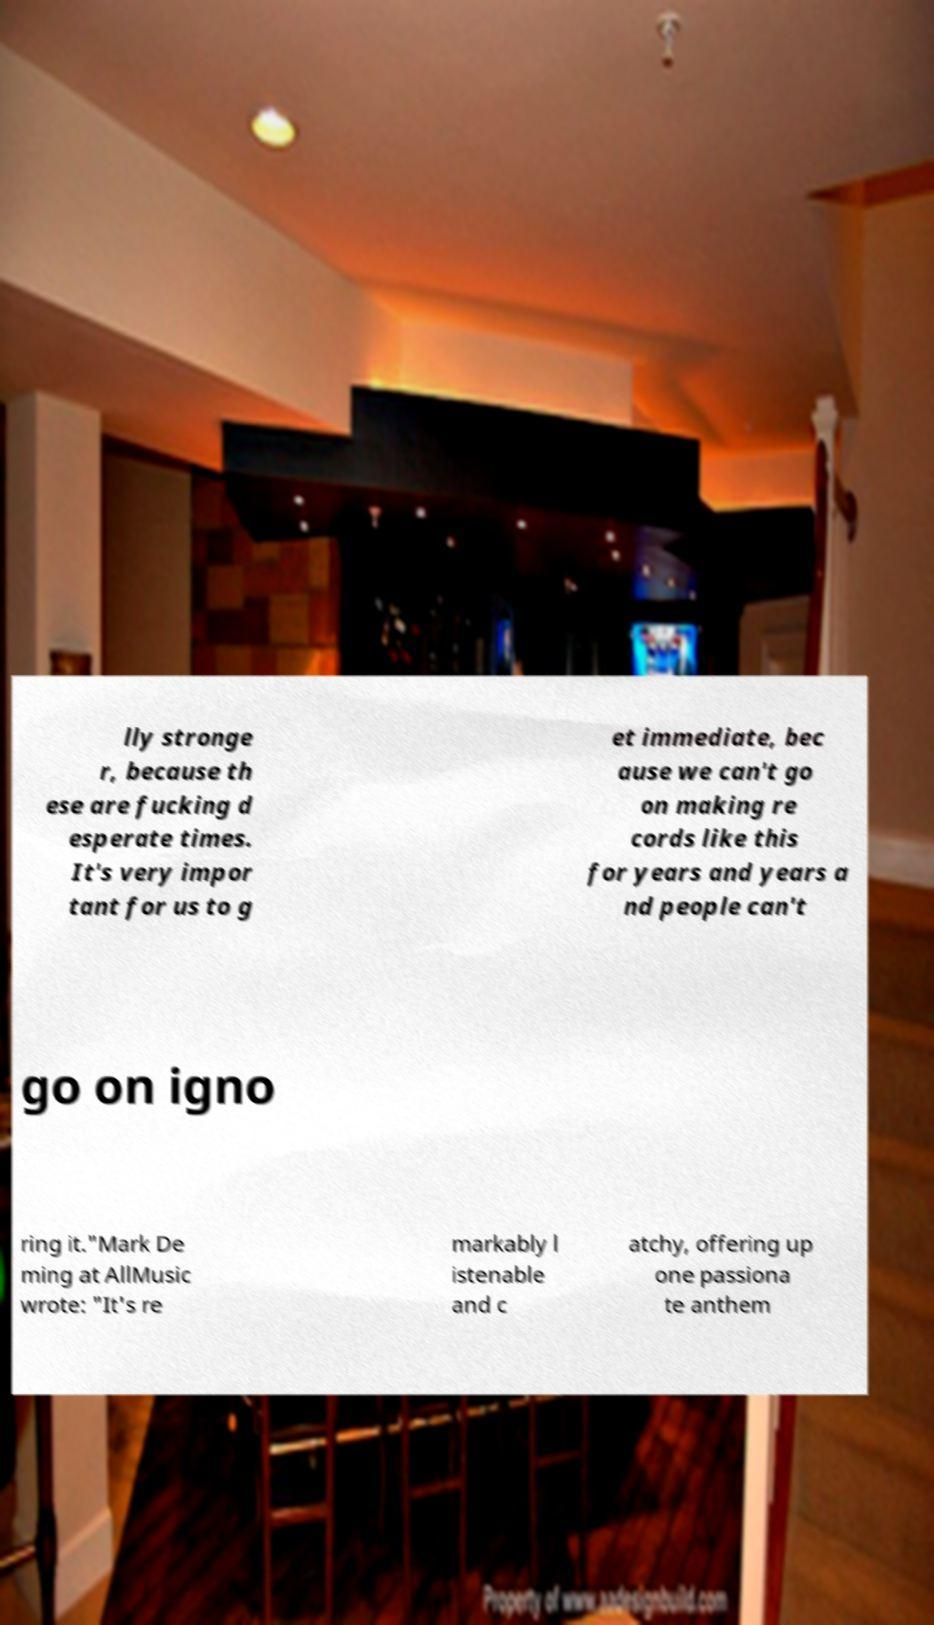Please read and relay the text visible in this image. What does it say? lly stronge r, because th ese are fucking d esperate times. It's very impor tant for us to g et immediate, bec ause we can't go on making re cords like this for years and years a nd people can't go on igno ring it."Mark De ming at AllMusic wrote: "It's re markably l istenable and c atchy, offering up one passiona te anthem 